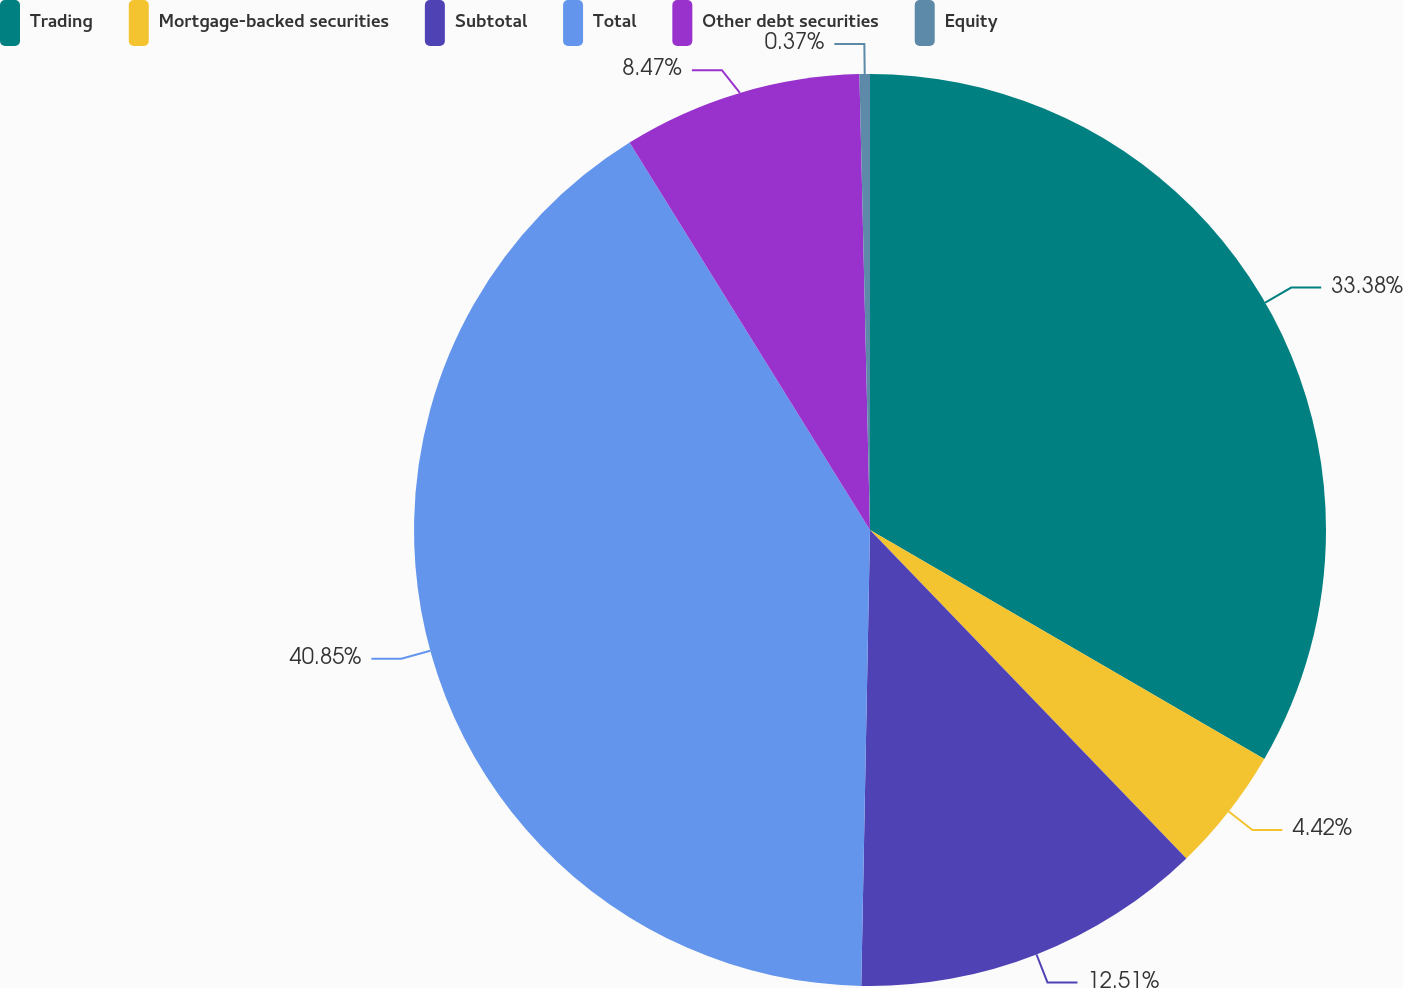<chart> <loc_0><loc_0><loc_500><loc_500><pie_chart><fcel>Trading<fcel>Mortgage-backed securities<fcel>Subtotal<fcel>Total<fcel>Other debt securities<fcel>Equity<nl><fcel>33.38%<fcel>4.42%<fcel>12.51%<fcel>40.86%<fcel>8.47%<fcel>0.37%<nl></chart> 